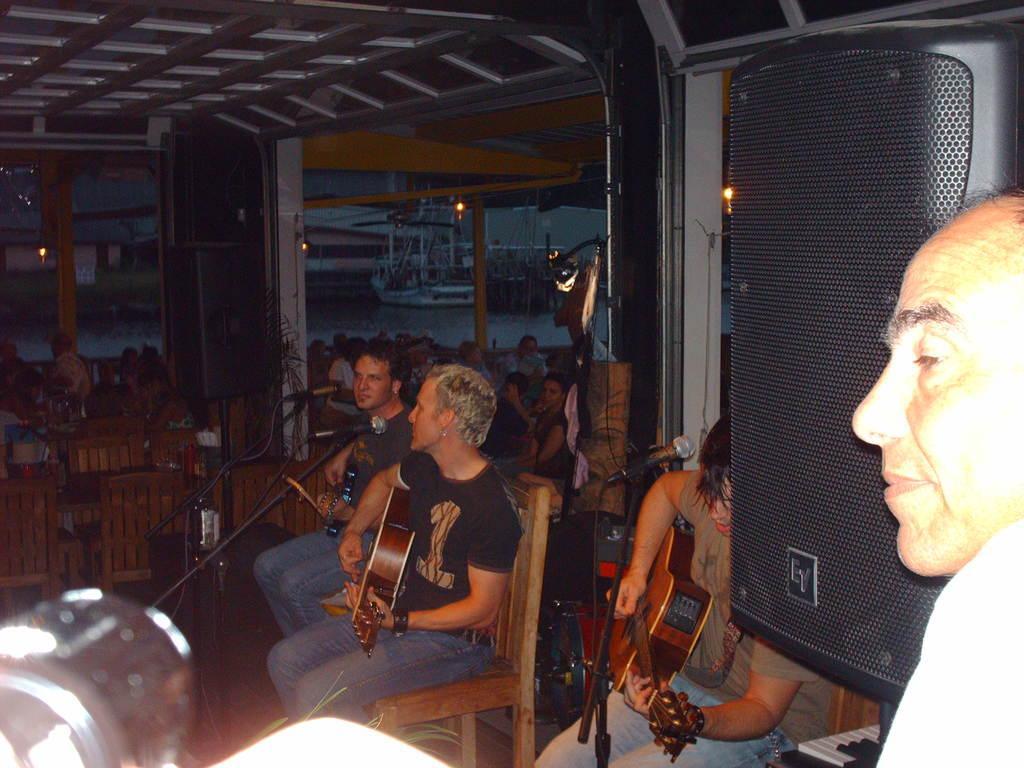How would you summarize this image in a sentence or two? In this image, there are some chairs which are in yellow color and in the middle there are some people sitting on the chairs they are holding some music instrument, there are some microphones which are in black color, in the background there are some people sitting on the chairs. 